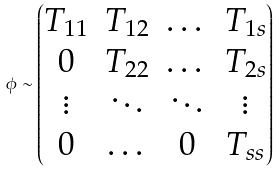Convert formula to latex. <formula><loc_0><loc_0><loc_500><loc_500>\phi \sim \begin{pmatrix} T _ { 1 1 } & T _ { 1 2 } & \dots & T _ { 1 s } \\ 0 & T _ { 2 2 } & \dots & T _ { 2 s } \\ \vdots & \ddots & \ddots & \vdots \\ 0 & \dots & 0 & T _ { s s } \end{pmatrix}</formula> 